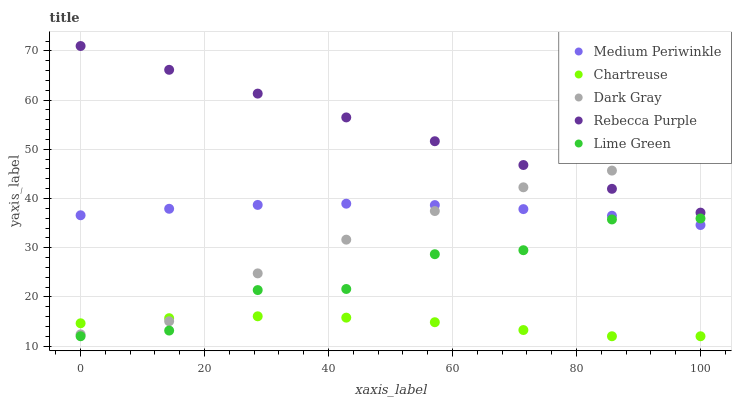Does Chartreuse have the minimum area under the curve?
Answer yes or no. Yes. Does Rebecca Purple have the maximum area under the curve?
Answer yes or no. Yes. Does Lime Green have the minimum area under the curve?
Answer yes or no. No. Does Lime Green have the maximum area under the curve?
Answer yes or no. No. Is Rebecca Purple the smoothest?
Answer yes or no. Yes. Is Lime Green the roughest?
Answer yes or no. Yes. Is Chartreuse the smoothest?
Answer yes or no. No. Is Chartreuse the roughest?
Answer yes or no. No. Does Lime Green have the lowest value?
Answer yes or no. Yes. Does Medium Periwinkle have the lowest value?
Answer yes or no. No. Does Rebecca Purple have the highest value?
Answer yes or no. Yes. Does Lime Green have the highest value?
Answer yes or no. No. Is Medium Periwinkle less than Rebecca Purple?
Answer yes or no. Yes. Is Rebecca Purple greater than Lime Green?
Answer yes or no. Yes. Does Dark Gray intersect Chartreuse?
Answer yes or no. Yes. Is Dark Gray less than Chartreuse?
Answer yes or no. No. Is Dark Gray greater than Chartreuse?
Answer yes or no. No. Does Medium Periwinkle intersect Rebecca Purple?
Answer yes or no. No. 